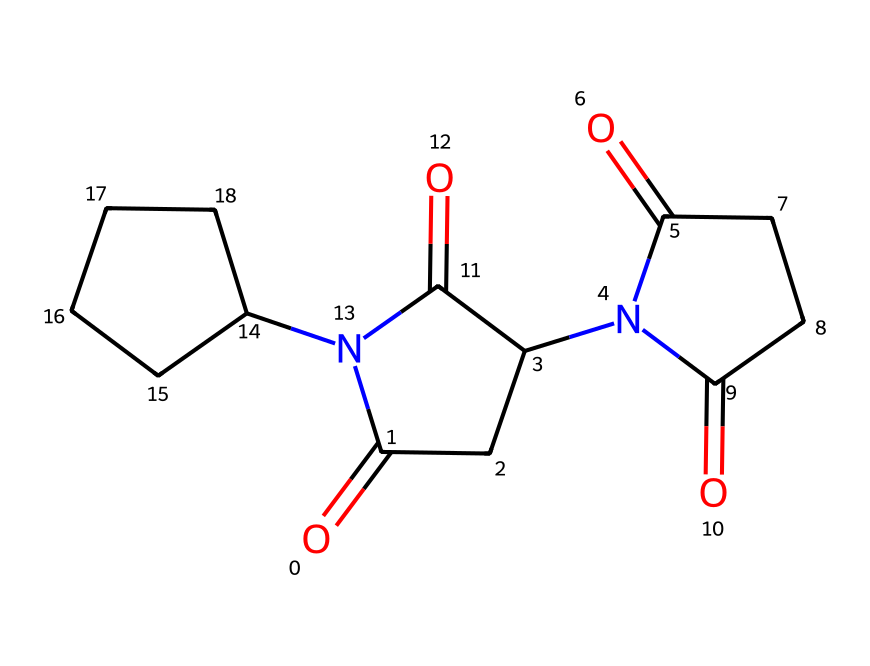What is the molecular formula of thalidomide? To determine the molecular formula, we count the number of each type of atom in the chemical structure. In the given SMILES representation, there are 13 carbons (C), 13 hydrogens (H), 4 nitrogens (N), and 3 oxygens (O). Therefore, the molecular formula is C13H13N3O4.
Answer: C13H13N3O4 How many stereocenters are present in thalidomide? A stereocenter is typically a carbon atom bonded to four different substituents. By analyzing the structure, we can identify two carbon atoms in thalidomide that meet this criterion, making it chiral with two stereocenters.
Answer: 2 What type of isomerism is exhibited by thalidomide? Thalidomide exhibits enantiomerism, which arises due to its chirality and the presence of two stereocenters. Each stereocenter can exist in two configurations, leading to the formation of non-superimposable mirror images, or enantiomers.
Answer: enantiomerism What are the potential effects of thalidomide's enantiomers? The R-enantiomer of thalidomide is effective as a sedative and anti-inflammatory, while the S-enantiomer is responsible for teratogenic effects, causing severe birth defects. Understanding the different effects is crucial in evaluating drug safety and efficacy.
Answer: different effects Why is chirality important in thalidomide's pharmacological action? Chirality is significant because the two enantiomers can have drastically different biological activities and effects. The R-enantiomer is therapeutic, while the S-enantiomer can lead to harm, highlighting the importance of stereochemistry in drug development.
Answer: pharmacological action 